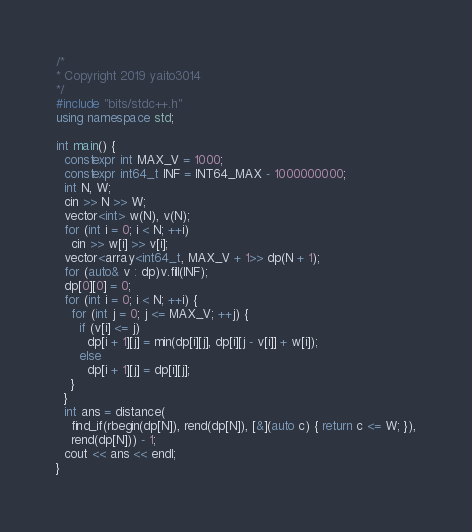<code> <loc_0><loc_0><loc_500><loc_500><_C++_>/*
* Copyright 2019 yaito3014
*/
#include "bits/stdc++.h"
using namespace std;

int main() {
  constexpr int MAX_V = 1000;
  constexpr int64_t INF = INT64_MAX - 1000000000;
  int N, W;
  cin >> N >> W;
  vector<int> w(N), v(N);
  for (int i = 0; i < N; ++i)
    cin >> w[i] >> v[i];
  vector<array<int64_t, MAX_V + 1>> dp(N + 1);
  for (auto& v : dp)v.fill(INF);
  dp[0][0] = 0;
  for (int i = 0; i < N; ++i) {
    for (int j = 0; j <= MAX_V; ++j) {
      if (v[i] <= j)
        dp[i + 1][j] = min(dp[i][j], dp[i][j - v[i]] + w[i]);
      else
        dp[i + 1][j] = dp[i][j];
    }
  }
  int ans = distance(
    find_if(rbegin(dp[N]), rend(dp[N]), [&](auto c) { return c <= W; }),
    rend(dp[N])) - 1;
  cout << ans << endl;
}
</code> 